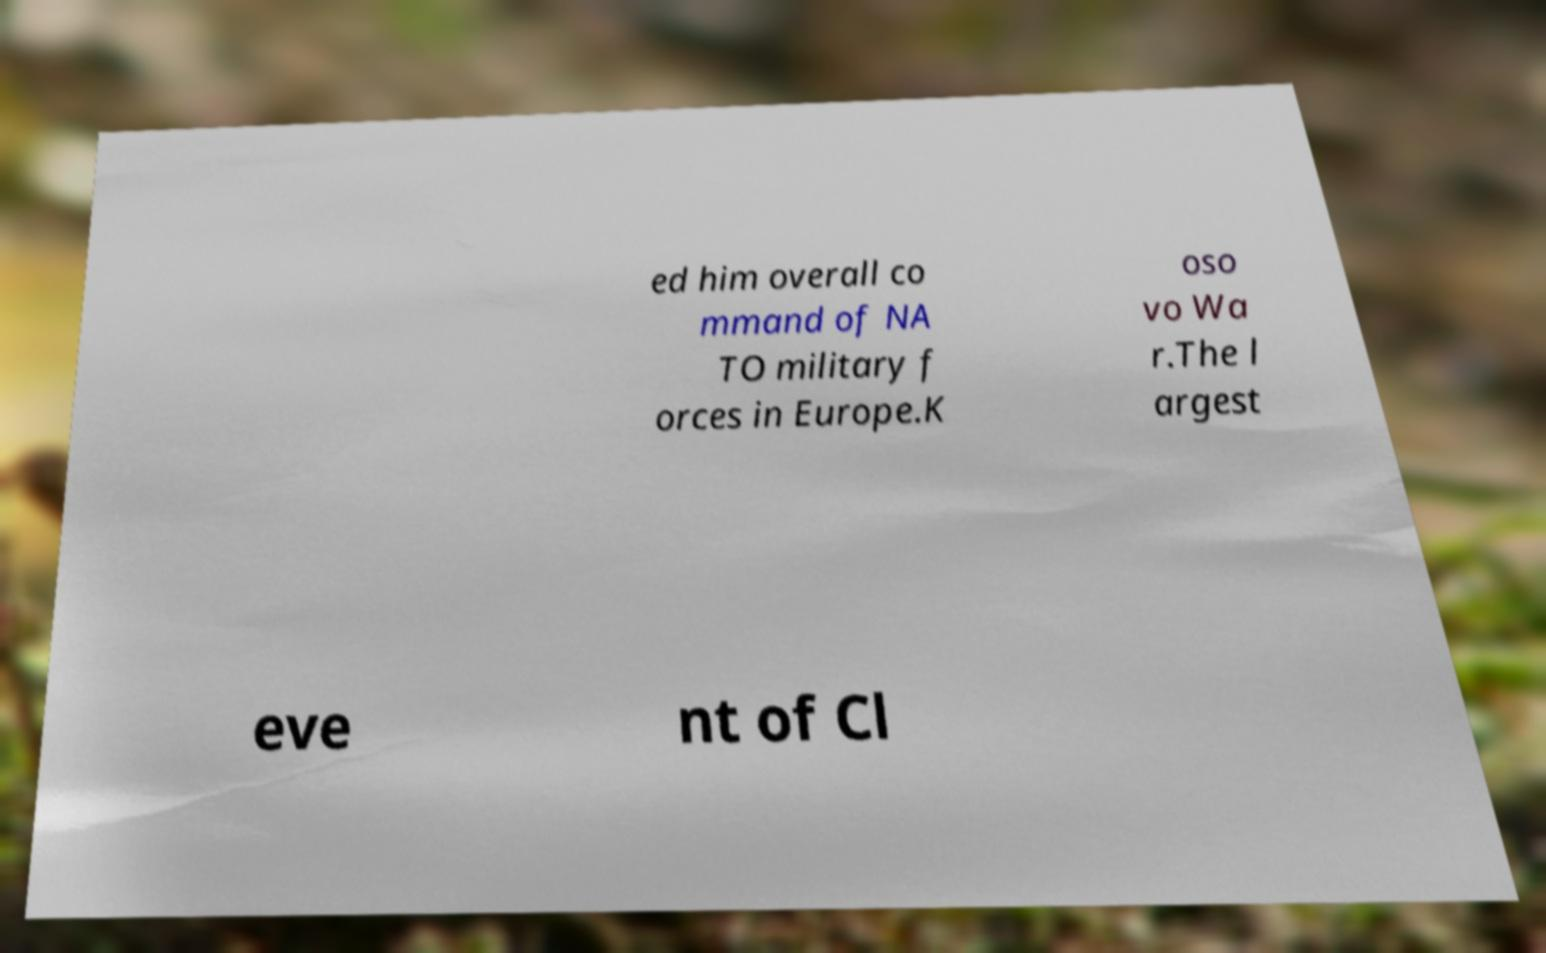Could you extract and type out the text from this image? ed him overall co mmand of NA TO military f orces in Europe.K oso vo Wa r.The l argest eve nt of Cl 